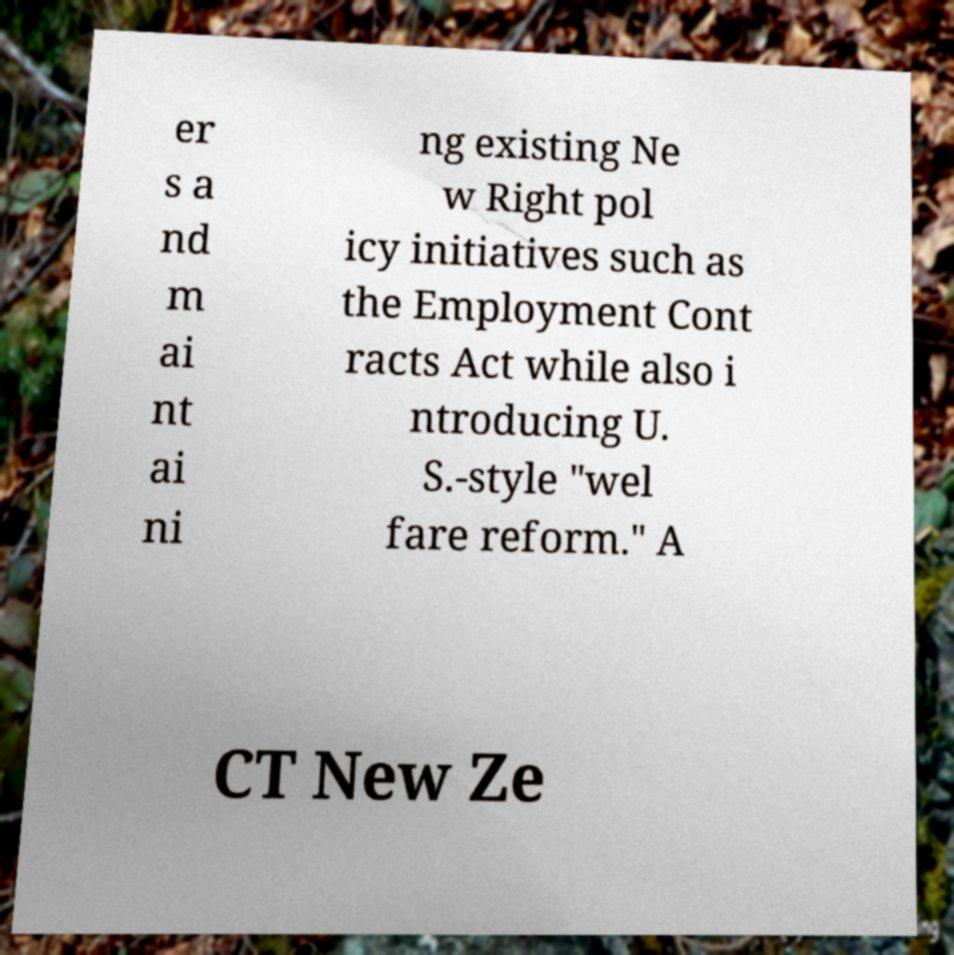Could you extract and type out the text from this image? er s a nd m ai nt ai ni ng existing Ne w Right pol icy initiatives such as the Employment Cont racts Act while also i ntroducing U. S.-style "wel fare reform." A CT New Ze 